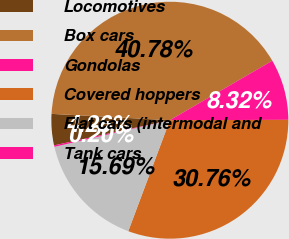<chart> <loc_0><loc_0><loc_500><loc_500><pie_chart><fcel>Locomotives<fcel>Box cars<fcel>Gondolas<fcel>Covered hoppers<fcel>Flat cars (intermodal and<fcel>Tank cars<nl><fcel>4.26%<fcel>40.78%<fcel>8.32%<fcel>30.76%<fcel>15.69%<fcel>0.2%<nl></chart> 